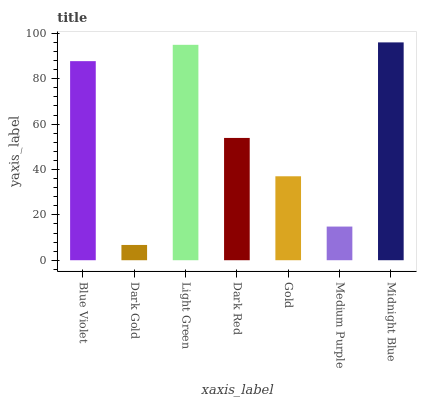Is Dark Gold the minimum?
Answer yes or no. Yes. Is Midnight Blue the maximum?
Answer yes or no. Yes. Is Light Green the minimum?
Answer yes or no. No. Is Light Green the maximum?
Answer yes or no. No. Is Light Green greater than Dark Gold?
Answer yes or no. Yes. Is Dark Gold less than Light Green?
Answer yes or no. Yes. Is Dark Gold greater than Light Green?
Answer yes or no. No. Is Light Green less than Dark Gold?
Answer yes or no. No. Is Dark Red the high median?
Answer yes or no. Yes. Is Dark Red the low median?
Answer yes or no. Yes. Is Midnight Blue the high median?
Answer yes or no. No. Is Gold the low median?
Answer yes or no. No. 